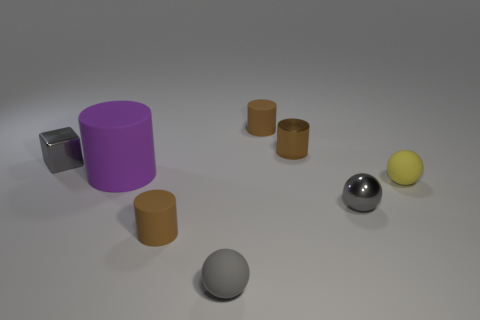Subtract all cyan spheres. How many brown cylinders are left? 3 Add 2 blue matte balls. How many objects exist? 10 Subtract 1 spheres. How many spheres are left? 2 Subtract all gray balls. How many balls are left? 1 Subtract all cubes. How many objects are left? 7 Add 5 cyan matte spheres. How many cyan matte spheres exist? 5 Subtract 1 purple cylinders. How many objects are left? 7 Subtract all blue blocks. Subtract all blue cylinders. How many blocks are left? 1 Subtract all tiny yellow matte things. Subtract all small brown metallic objects. How many objects are left? 6 Add 5 large purple rubber cylinders. How many large purple rubber cylinders are left? 6 